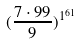<formula> <loc_0><loc_0><loc_500><loc_500>( \frac { 7 \cdot 9 9 } { 9 } ) ^ { 1 ^ { 6 1 } }</formula> 